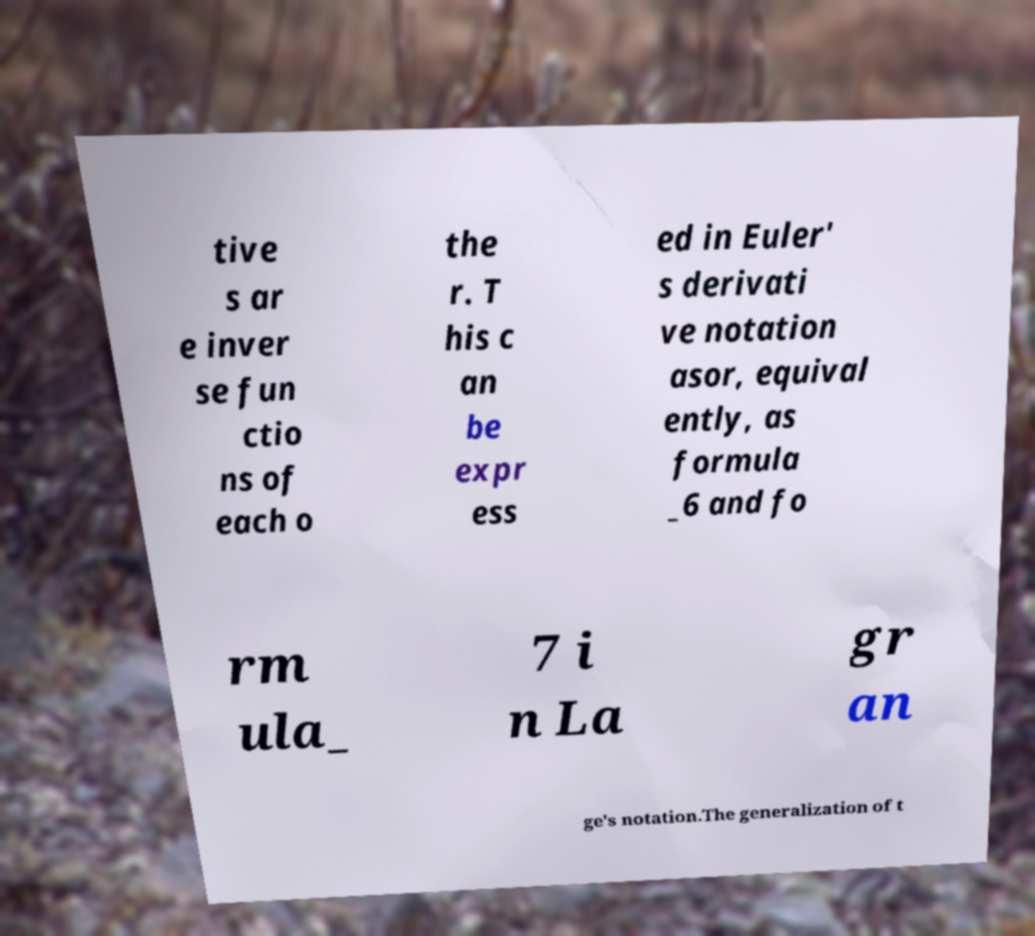Could you assist in decoding the text presented in this image and type it out clearly? tive s ar e inver se fun ctio ns of each o the r. T his c an be expr ess ed in Euler' s derivati ve notation asor, equival ently, as formula _6 and fo rm ula_ 7 i n La gr an ge's notation.The generalization of t 